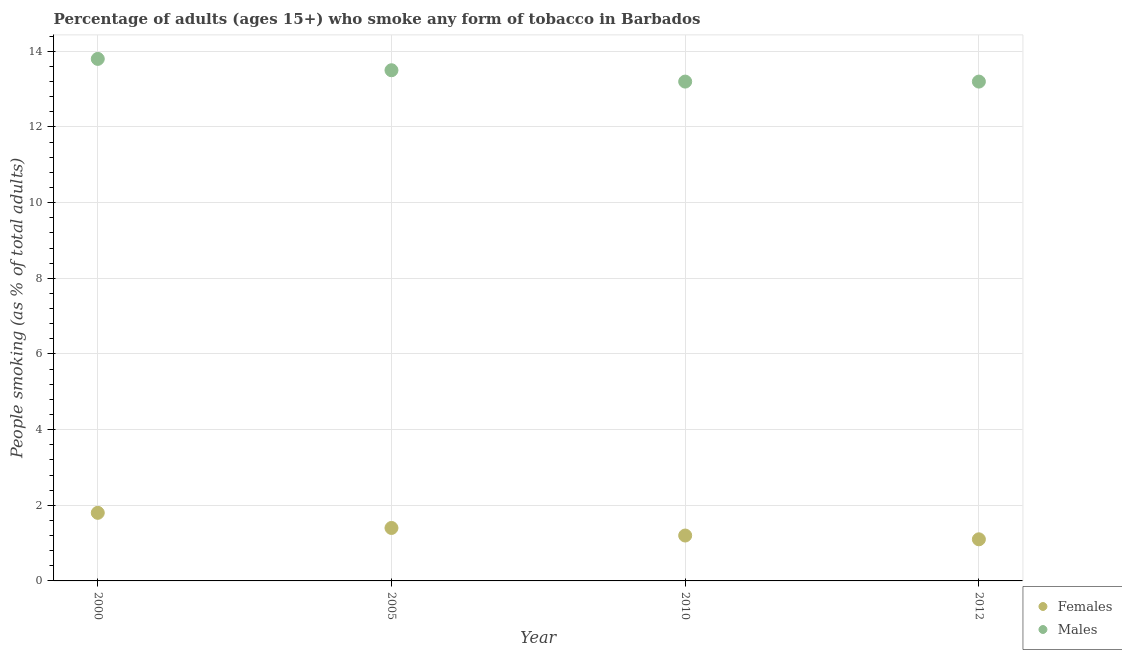How many different coloured dotlines are there?
Provide a succinct answer. 2. Is the number of dotlines equal to the number of legend labels?
Keep it short and to the point. Yes. Across all years, what is the minimum percentage of males who smoke?
Make the answer very short. 13.2. In which year was the percentage of males who smoke maximum?
Make the answer very short. 2000. In which year was the percentage of males who smoke minimum?
Your answer should be very brief. 2010. What is the total percentage of females who smoke in the graph?
Ensure brevity in your answer.  5.5. What is the difference between the percentage of males who smoke in 2000 and that in 2012?
Your response must be concise. 0.6. What is the difference between the percentage of males who smoke in 2010 and the percentage of females who smoke in 2005?
Ensure brevity in your answer.  11.8. What is the average percentage of females who smoke per year?
Offer a terse response. 1.38. What is the ratio of the percentage of females who smoke in 2000 to that in 2012?
Give a very brief answer. 1.64. Is the percentage of females who smoke in 2000 less than that in 2012?
Offer a terse response. No. Is the difference between the percentage of males who smoke in 2000 and 2012 greater than the difference between the percentage of females who smoke in 2000 and 2012?
Provide a short and direct response. No. What is the difference between the highest and the second highest percentage of females who smoke?
Your answer should be compact. 0.4. What is the difference between the highest and the lowest percentage of males who smoke?
Offer a very short reply. 0.6. In how many years, is the percentage of males who smoke greater than the average percentage of males who smoke taken over all years?
Offer a very short reply. 2. Is the sum of the percentage of males who smoke in 2000 and 2005 greater than the maximum percentage of females who smoke across all years?
Ensure brevity in your answer.  Yes. Is the percentage of males who smoke strictly greater than the percentage of females who smoke over the years?
Keep it short and to the point. Yes. How many dotlines are there?
Ensure brevity in your answer.  2. How many years are there in the graph?
Keep it short and to the point. 4. Does the graph contain any zero values?
Keep it short and to the point. No. How are the legend labels stacked?
Offer a very short reply. Vertical. What is the title of the graph?
Your response must be concise. Percentage of adults (ages 15+) who smoke any form of tobacco in Barbados. What is the label or title of the Y-axis?
Ensure brevity in your answer.  People smoking (as % of total adults). What is the People smoking (as % of total adults) of Females in 2000?
Ensure brevity in your answer.  1.8. What is the People smoking (as % of total adults) in Females in 2005?
Give a very brief answer. 1.4. What is the People smoking (as % of total adults) in Females in 2012?
Provide a short and direct response. 1.1. Across all years, what is the maximum People smoking (as % of total adults) of Males?
Ensure brevity in your answer.  13.8. Across all years, what is the minimum People smoking (as % of total adults) of Females?
Offer a very short reply. 1.1. What is the total People smoking (as % of total adults) in Females in the graph?
Provide a short and direct response. 5.5. What is the total People smoking (as % of total adults) in Males in the graph?
Keep it short and to the point. 53.7. What is the difference between the People smoking (as % of total adults) of Males in 2000 and that in 2010?
Your answer should be compact. 0.6. What is the difference between the People smoking (as % of total adults) of Females in 2005 and that in 2010?
Your answer should be very brief. 0.2. What is the difference between the People smoking (as % of total adults) of Females in 2005 and that in 2012?
Offer a very short reply. 0.3. What is the difference between the People smoking (as % of total adults) of Males in 2005 and that in 2012?
Your answer should be compact. 0.3. What is the difference between the People smoking (as % of total adults) in Females in 2010 and that in 2012?
Keep it short and to the point. 0.1. What is the difference between the People smoking (as % of total adults) in Females in 2000 and the People smoking (as % of total adults) in Males in 2005?
Provide a succinct answer. -11.7. What is the difference between the People smoking (as % of total adults) of Females in 2005 and the People smoking (as % of total adults) of Males in 2012?
Keep it short and to the point. -11.8. What is the average People smoking (as % of total adults) in Females per year?
Provide a short and direct response. 1.38. What is the average People smoking (as % of total adults) in Males per year?
Offer a very short reply. 13.43. In the year 2010, what is the difference between the People smoking (as % of total adults) in Females and People smoking (as % of total adults) in Males?
Your answer should be compact. -12. What is the ratio of the People smoking (as % of total adults) in Males in 2000 to that in 2005?
Ensure brevity in your answer.  1.02. What is the ratio of the People smoking (as % of total adults) of Females in 2000 to that in 2010?
Make the answer very short. 1.5. What is the ratio of the People smoking (as % of total adults) in Males in 2000 to that in 2010?
Provide a short and direct response. 1.05. What is the ratio of the People smoking (as % of total adults) in Females in 2000 to that in 2012?
Provide a short and direct response. 1.64. What is the ratio of the People smoking (as % of total adults) of Males in 2000 to that in 2012?
Provide a succinct answer. 1.05. What is the ratio of the People smoking (as % of total adults) in Males in 2005 to that in 2010?
Your answer should be compact. 1.02. What is the ratio of the People smoking (as % of total adults) in Females in 2005 to that in 2012?
Your answer should be compact. 1.27. What is the ratio of the People smoking (as % of total adults) in Males in 2005 to that in 2012?
Ensure brevity in your answer.  1.02. What is the ratio of the People smoking (as % of total adults) of Males in 2010 to that in 2012?
Provide a short and direct response. 1. What is the difference between the highest and the second highest People smoking (as % of total adults) in Females?
Your answer should be very brief. 0.4. What is the difference between the highest and the second highest People smoking (as % of total adults) of Males?
Your answer should be very brief. 0.3. What is the difference between the highest and the lowest People smoking (as % of total adults) in Males?
Offer a terse response. 0.6. 